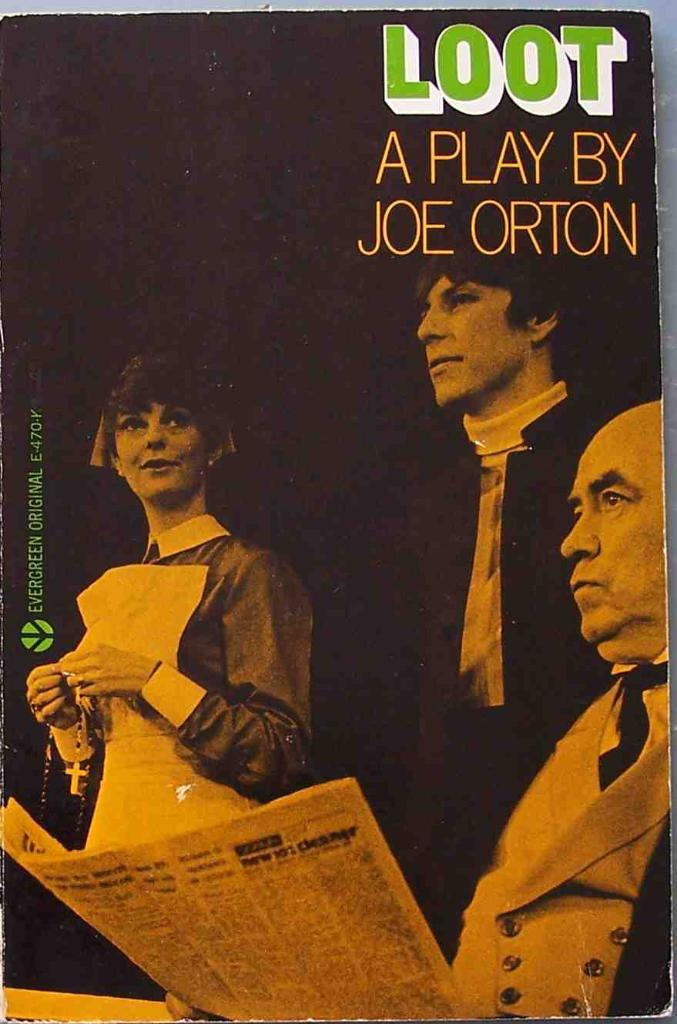<image>
Offer a succinct explanation of the picture presented. An old image of someone reading the newspaper says "Loot" at the top of it. 